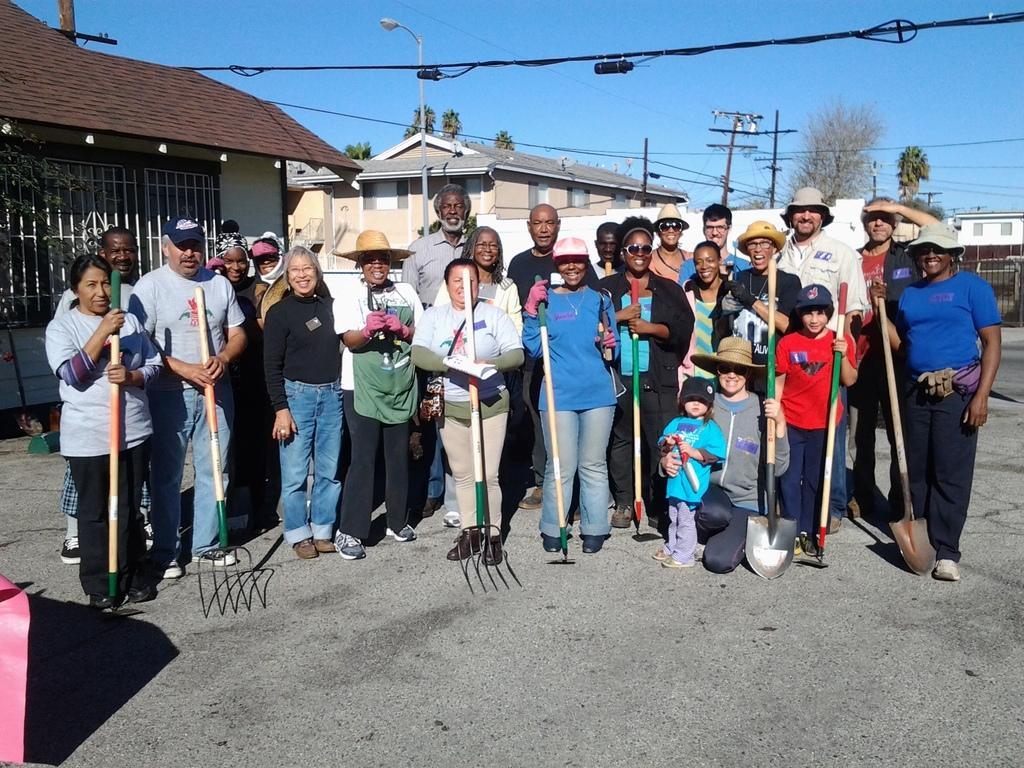In one or two sentences, can you explain what this image depicts? In this picture I can observe some people standing on the land. Some of them are holding digging tools in their hands. There are men and women. I can observe two children. In the background there are houses, trees and a sky. 